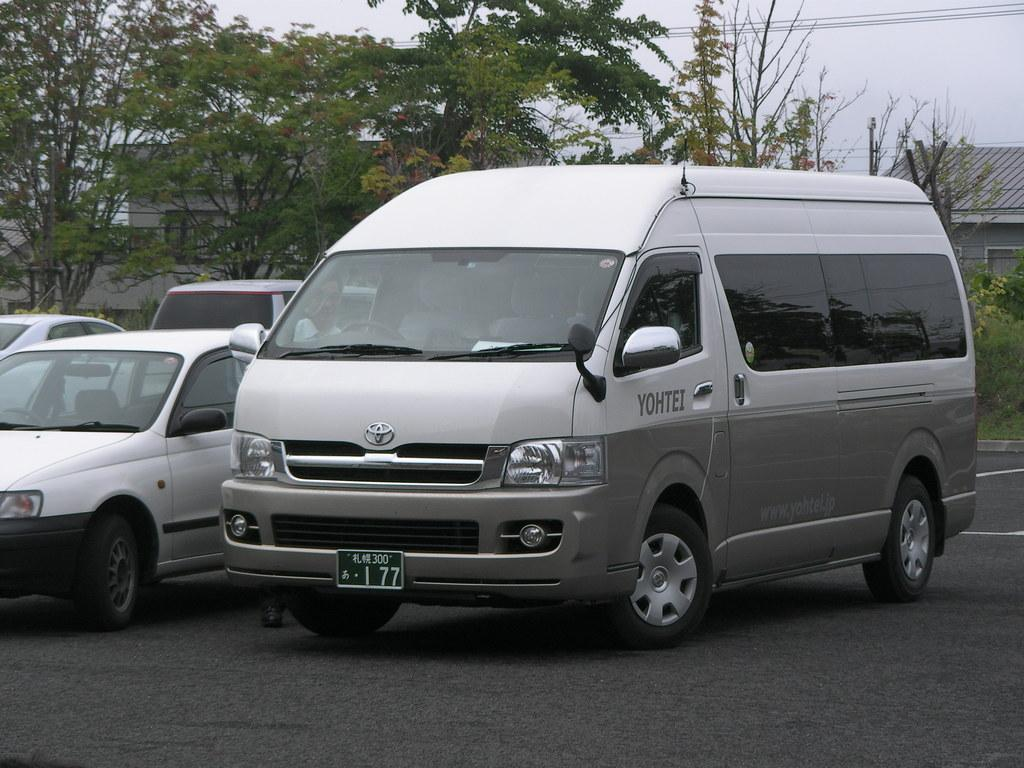<image>
Share a concise interpretation of the image provided. A large silver van sits in a car park with YOHTEI written on its side. 